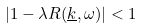Convert formula to latex. <formula><loc_0><loc_0><loc_500><loc_500>| 1 - \lambda R ( \underline { k } , \omega ) | < 1</formula> 